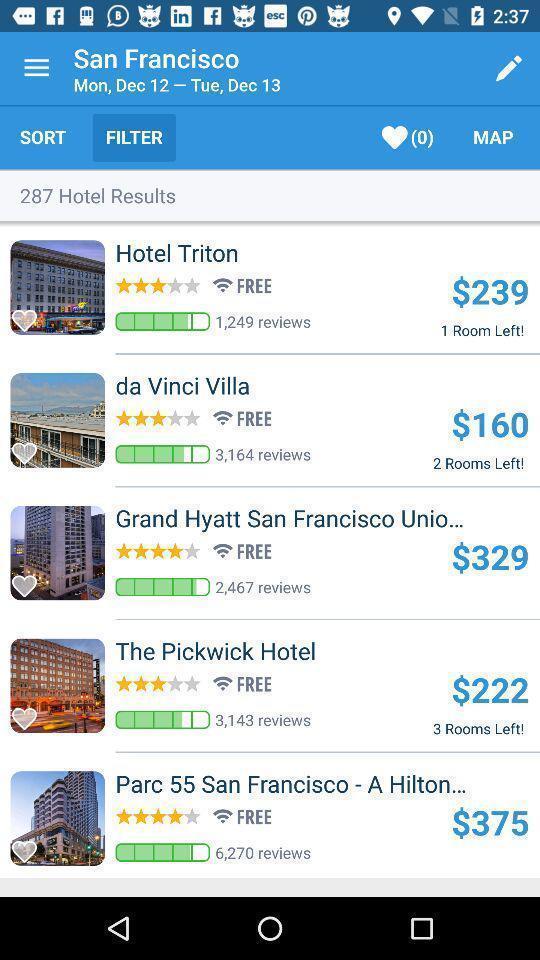What details can you identify in this image? Page showing options available in search filter. 